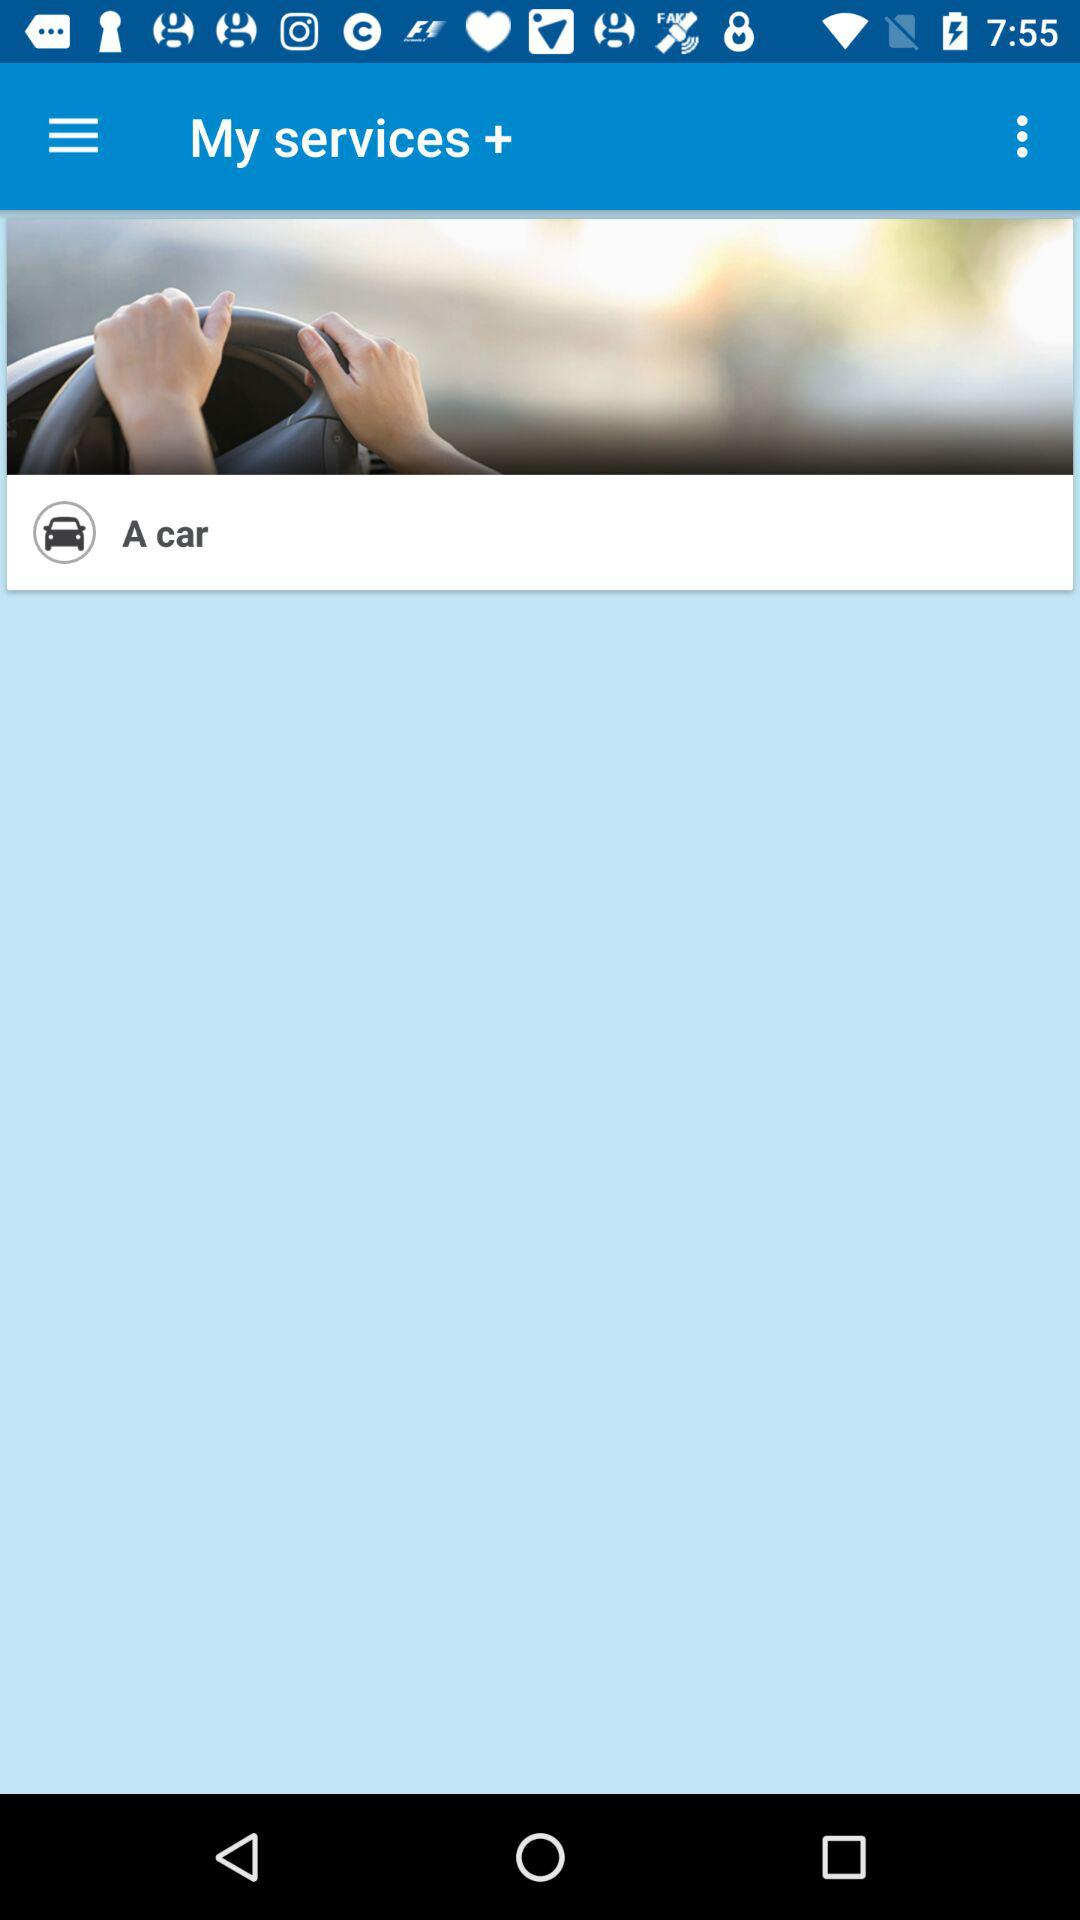What is the application name? The application name is "My services +". 